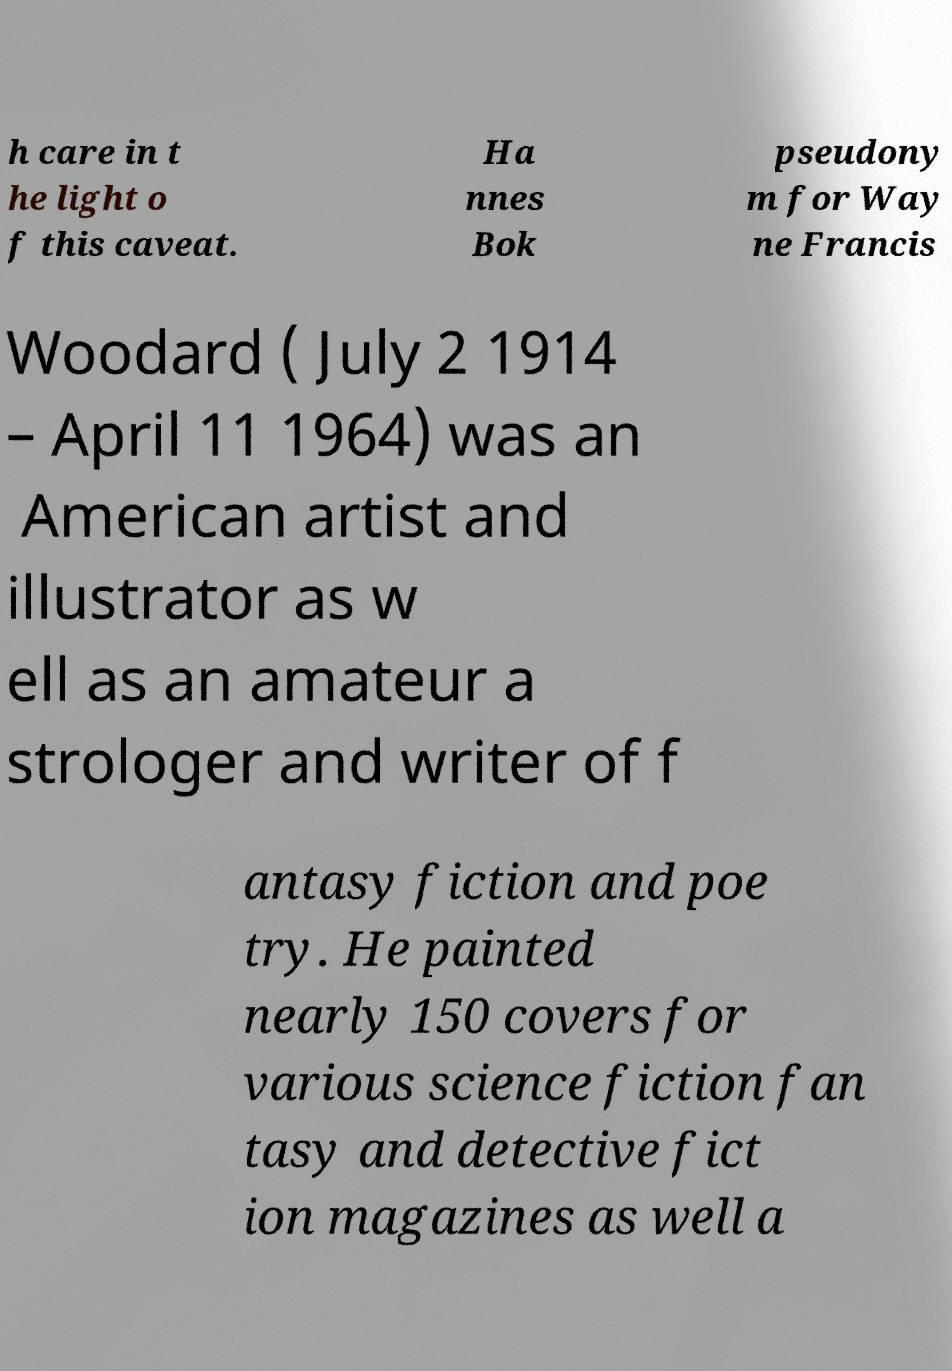There's text embedded in this image that I need extracted. Can you transcribe it verbatim? h care in t he light o f this caveat. Ha nnes Bok pseudony m for Way ne Francis Woodard ( July 2 1914 – April 11 1964) was an American artist and illustrator as w ell as an amateur a strologer and writer of f antasy fiction and poe try. He painted nearly 150 covers for various science fiction fan tasy and detective fict ion magazines as well a 